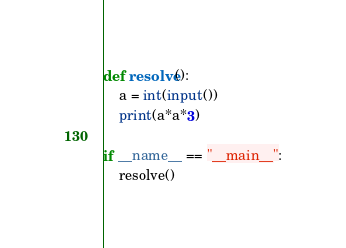Convert code to text. <code><loc_0><loc_0><loc_500><loc_500><_Python_>def resolve():
    a = int(input())
    print(a*a*3)

if __name__ == "__main__":
    resolve()</code> 